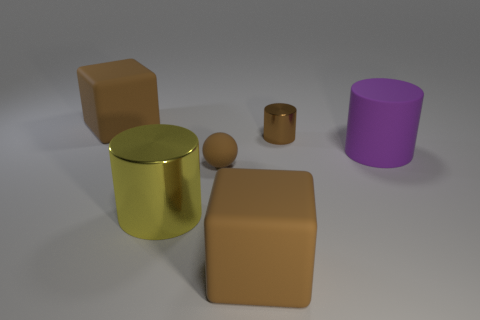Add 3 cyan spheres. How many objects exist? 9 Subtract all blocks. How many objects are left? 4 Subtract 1 purple cylinders. How many objects are left? 5 Subtract all brown rubber balls. Subtract all matte balls. How many objects are left? 4 Add 6 purple things. How many purple things are left? 7 Add 2 red metal cylinders. How many red metal cylinders exist? 2 